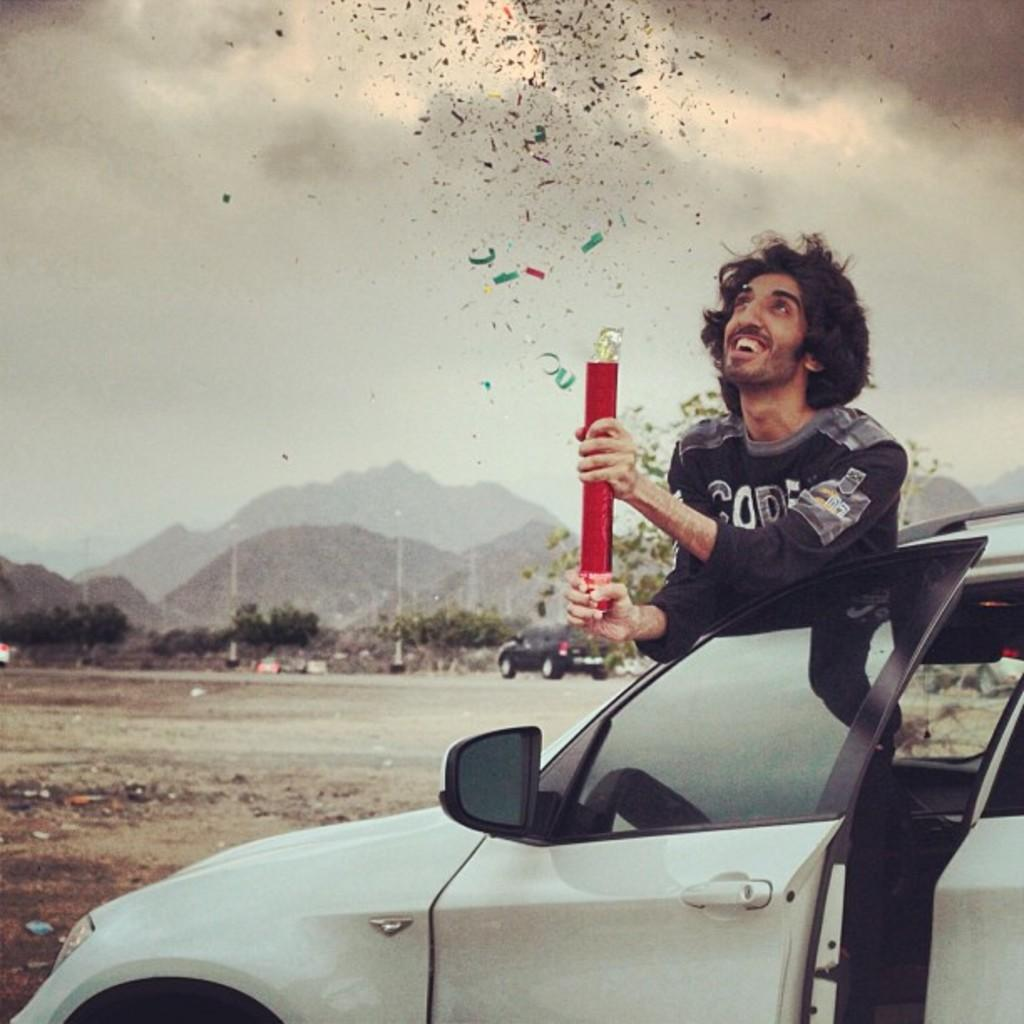What is the main subject of the image? The main subject of the image is a man standing between car doors. What is the man doing in the image? The man is popping glitters in the sky. What can be seen in the background of the image? There are mountains visible in the background of the image. What vehicle is present in the image? There is a car in the image. What type of heart-shaped object can be seen in the image? There is no heart-shaped object present in the image. Is there a meeting taking place in the image? There is no indication of a meeting in the image. 